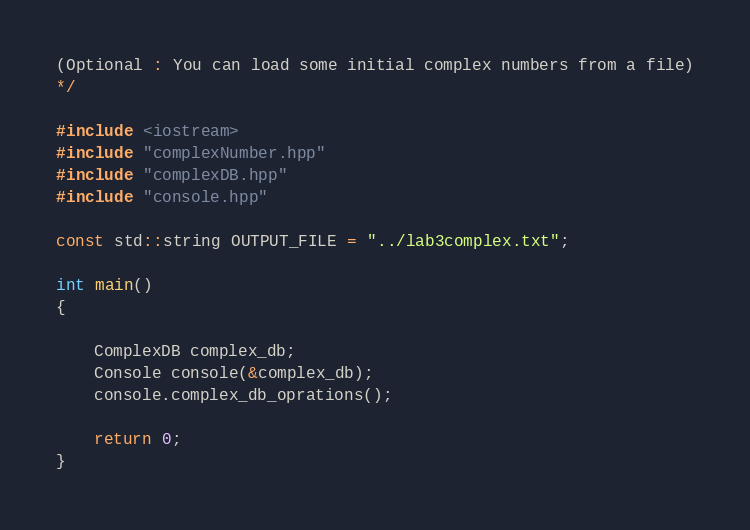<code> <loc_0><loc_0><loc_500><loc_500><_C++_>(Optional : You can load some initial complex numbers from a file)
*/

#include <iostream>
#include "complexNumber.hpp"
#include "complexDB.hpp"
#include "console.hpp"

const std::string OUTPUT_FILE = "../lab3complex.txt";

int main()
{
    
    ComplexDB complex_db;
    Console console(&complex_db);
    console.complex_db_oprations();

    return 0;
}
</code> 